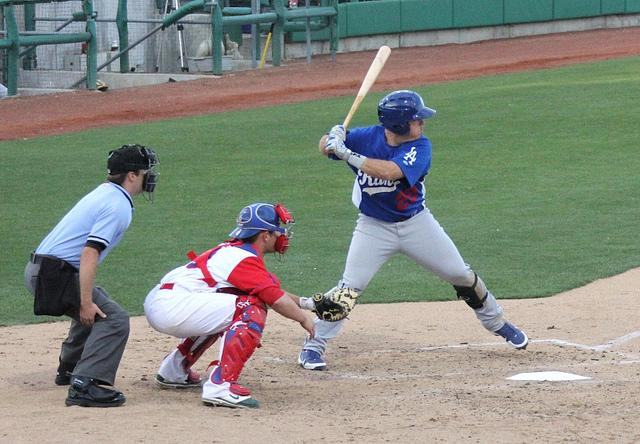What will the next thing the pitcher does? throw ball 